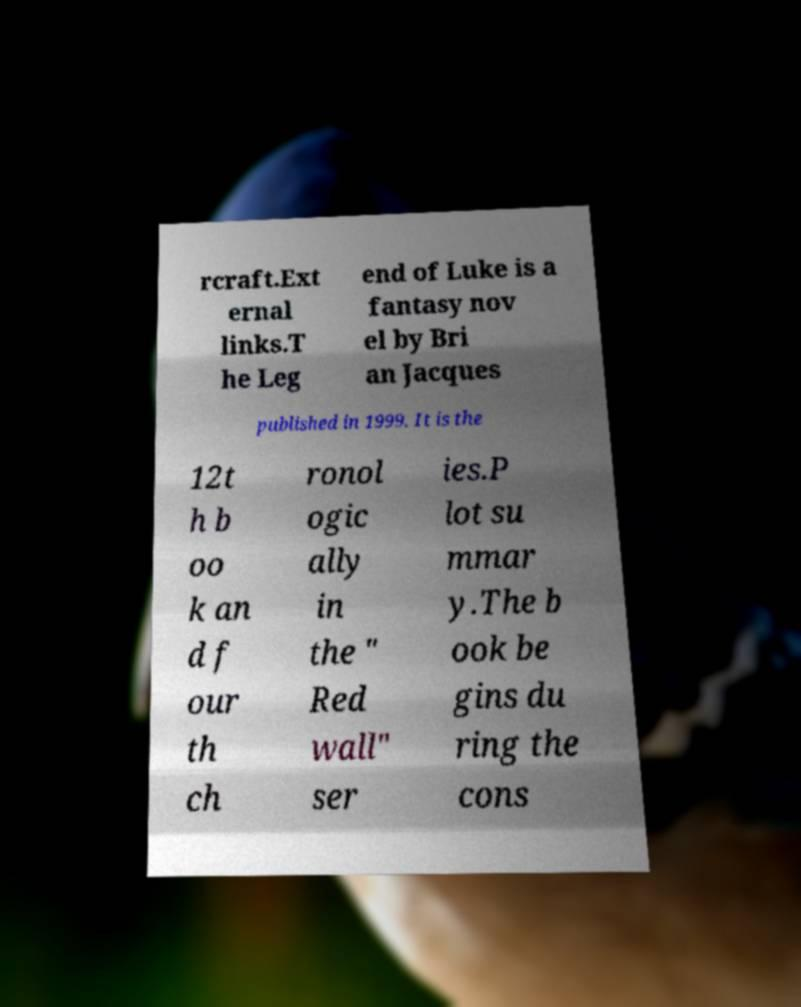Could you extract and type out the text from this image? rcraft.Ext ernal links.T he Leg end of Luke is a fantasy nov el by Bri an Jacques published in 1999. It is the 12t h b oo k an d f our th ch ronol ogic ally in the " Red wall" ser ies.P lot su mmar y.The b ook be gins du ring the cons 